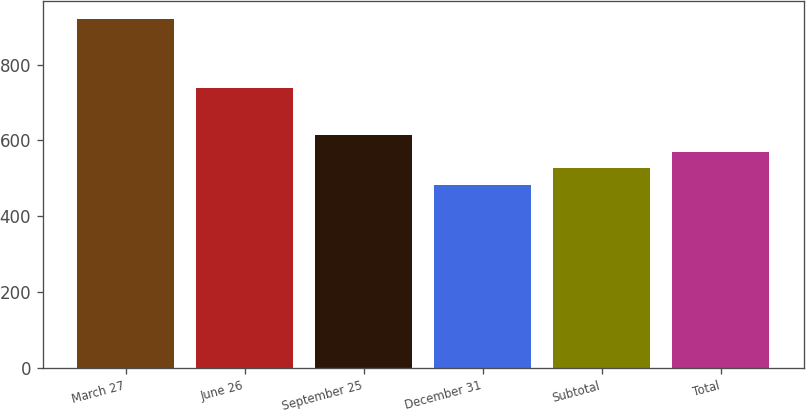<chart> <loc_0><loc_0><loc_500><loc_500><bar_chart><fcel>March 27<fcel>June 26<fcel>September 25<fcel>December 31<fcel>Subtotal<fcel>Total<nl><fcel>921<fcel>738<fcel>613.7<fcel>482<fcel>525.9<fcel>569.8<nl></chart> 